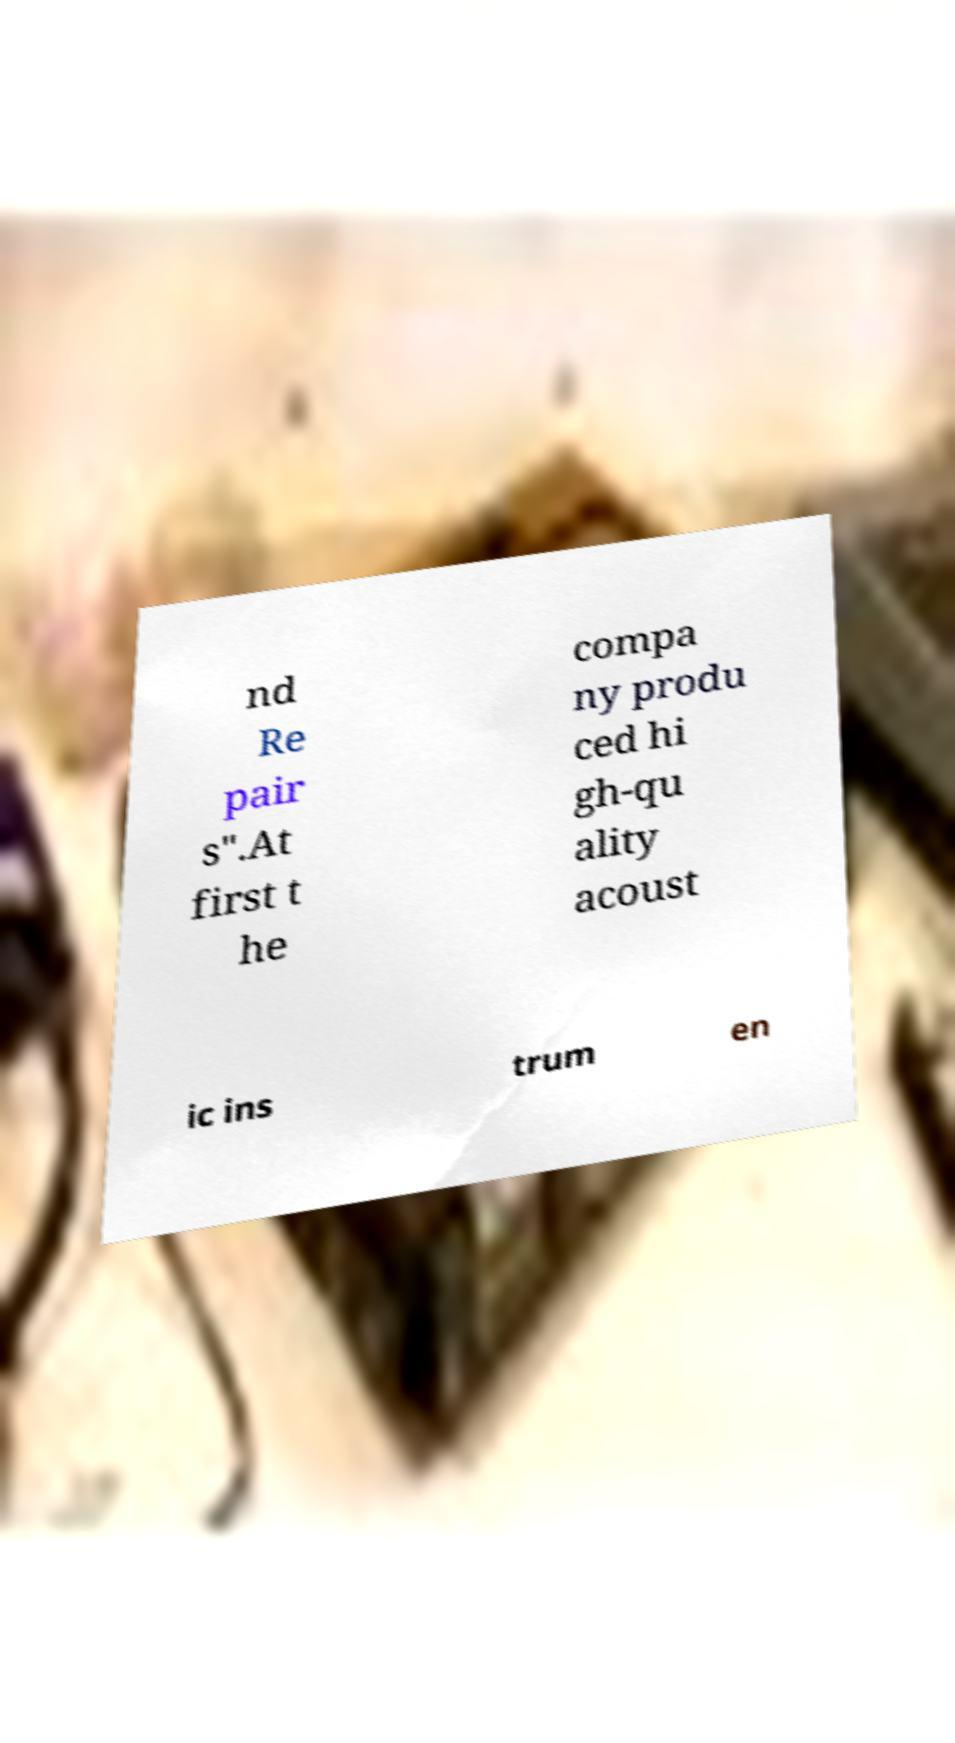Please read and relay the text visible in this image. What does it say? nd Re pair s".At first t he compa ny produ ced hi gh-qu ality acoust ic ins trum en 